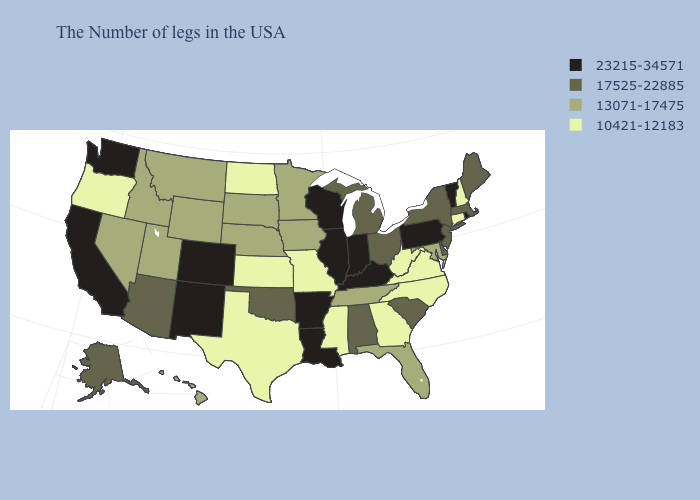Which states hav the highest value in the MidWest?
Give a very brief answer. Indiana, Wisconsin, Illinois. Does Wyoming have the highest value in the West?
Be succinct. No. What is the value of New Hampshire?
Be succinct. 10421-12183. Among the states that border California , does Nevada have the lowest value?
Short answer required. No. Which states have the lowest value in the USA?
Write a very short answer. New Hampshire, Connecticut, Virginia, North Carolina, West Virginia, Georgia, Mississippi, Missouri, Kansas, Texas, North Dakota, Oregon. Is the legend a continuous bar?
Answer briefly. No. Among the states that border Pennsylvania , which have the lowest value?
Short answer required. West Virginia. Which states hav the highest value in the West?
Give a very brief answer. Colorado, New Mexico, California, Washington. Name the states that have a value in the range 13071-17475?
Concise answer only. Maryland, Florida, Tennessee, Minnesota, Iowa, Nebraska, South Dakota, Wyoming, Utah, Montana, Idaho, Nevada, Hawaii. Does the first symbol in the legend represent the smallest category?
Concise answer only. No. What is the value of Virginia?
Be succinct. 10421-12183. Which states have the lowest value in the USA?
Be succinct. New Hampshire, Connecticut, Virginia, North Carolina, West Virginia, Georgia, Mississippi, Missouri, Kansas, Texas, North Dakota, Oregon. Among the states that border West Virginia , does Ohio have the lowest value?
Answer briefly. No. How many symbols are there in the legend?
Be succinct. 4. What is the highest value in states that border North Carolina?
Short answer required. 17525-22885. 